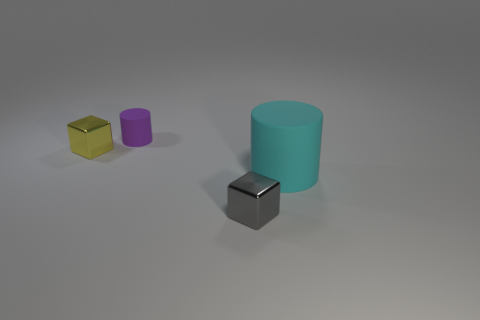Are there any small objects?
Keep it short and to the point. Yes. There is a big cyan object that is the same shape as the tiny purple rubber thing; what is its material?
Your answer should be very brief. Rubber. How big is the matte thing that is behind the block to the left of the small metal object to the right of the tiny rubber thing?
Provide a short and direct response. Small. Are there any small cylinders behind the small purple cylinder?
Make the answer very short. No. What is the size of the purple thing that is made of the same material as the big cyan cylinder?
Ensure brevity in your answer.  Small. How many other big rubber objects are the same shape as the large cyan thing?
Ensure brevity in your answer.  0. Are the tiny purple cylinder and the tiny yellow object left of the large cylinder made of the same material?
Make the answer very short. No. Is the number of small rubber cylinders behind the small gray metallic block greater than the number of tiny brown cylinders?
Your response must be concise. Yes. Are there any tiny gray cubes that have the same material as the big thing?
Your answer should be compact. No. Are the tiny block on the right side of the small yellow metal object and the cylinder in front of the yellow cube made of the same material?
Provide a short and direct response. No. 